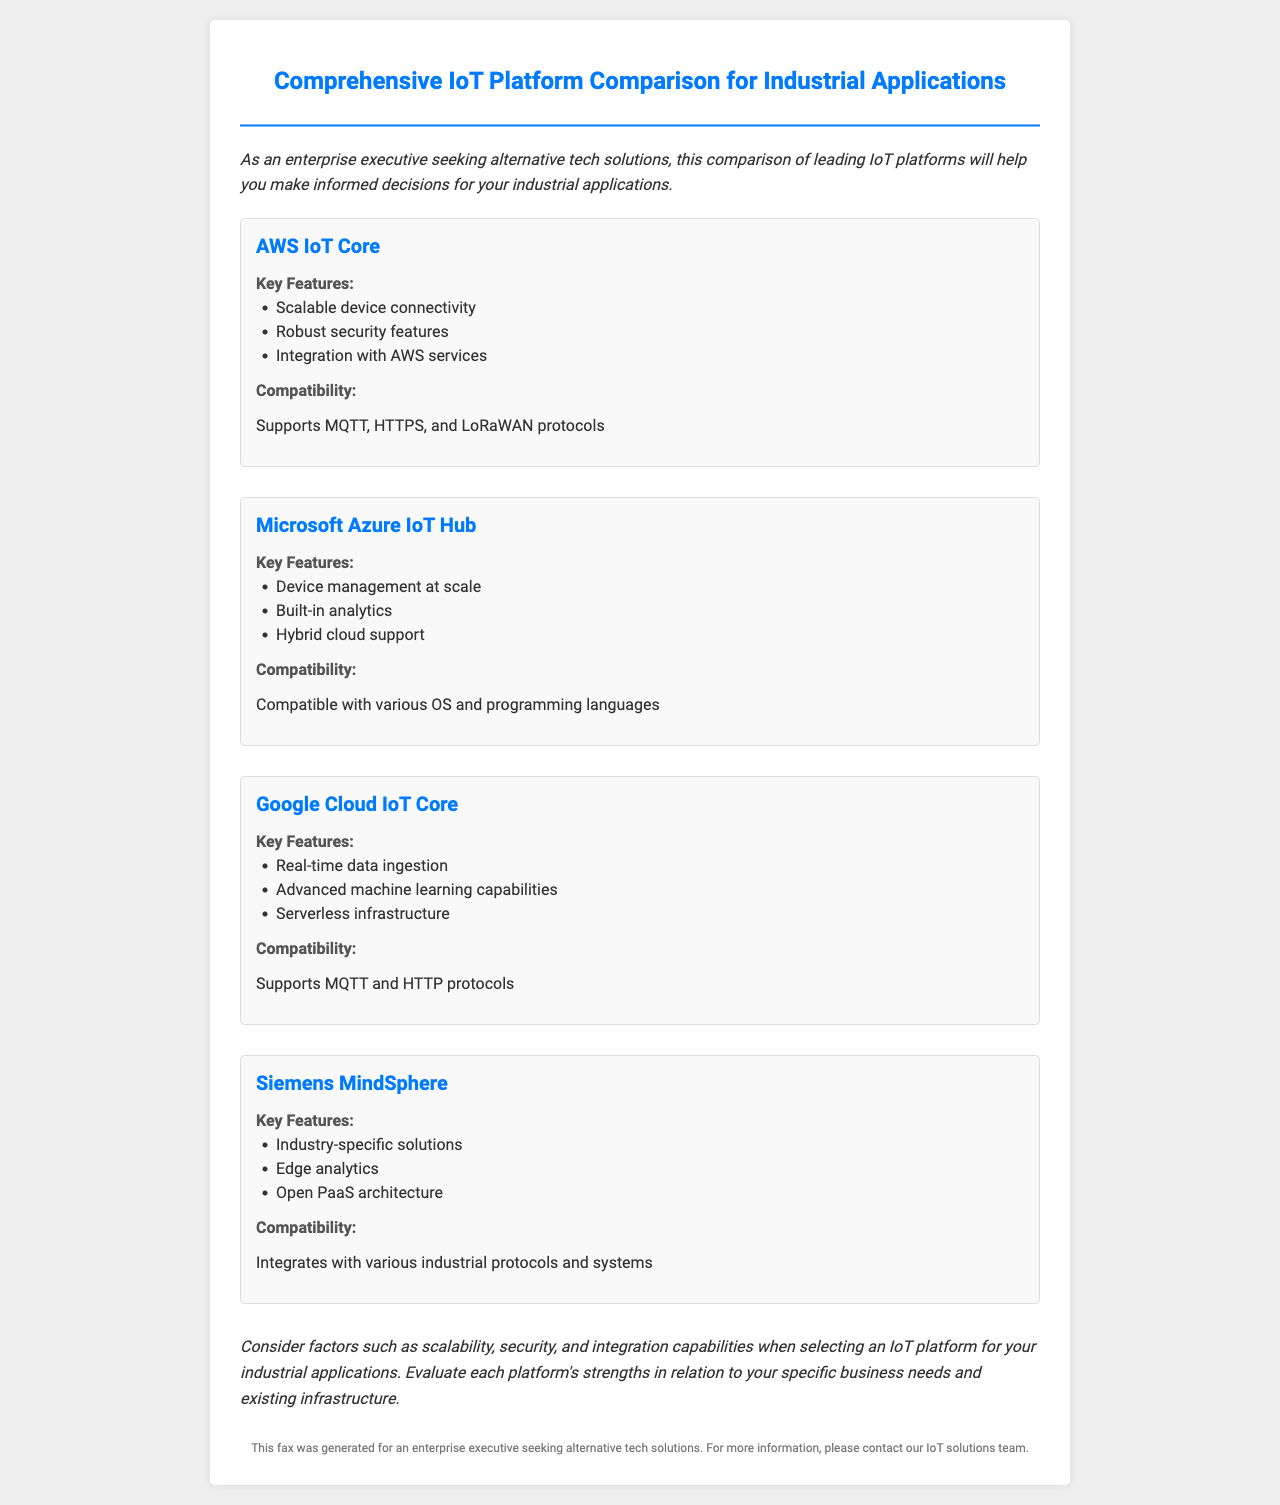what is the title of the document? The title of the document is indicated in the header, which provides an overview of the content.
Answer: Comprehensive IoT Platform Comparison for Industrial Applications how many IoT platforms are compared in the document? The document presents a total of four different IoT platforms for comparison.
Answer: Four what key feature is highlighted for AWS IoT Core? The document lists key features for each platform, with specific emphasis on AWS IoT Core's capabilities.
Answer: Scalable device connectivity which protocol is supported by Google Cloud IoT Core? The compatibility section mentions the supported protocols for Google Cloud IoT Core.
Answer: MQTT and HTTP what is a key feature of Siemens MindSphere? Each platform has distinct key features, and Siemens MindSphere is noted for its specific strengths.
Answer: Industry-specific solutions which platform supports hybrid cloud? The document describes each platform's capabilities related to cloud support.
Answer: Microsoft Azure IoT Hub what is the purpose of this comparison fax? The introduction of the document outlines the objective of providing insights for decision-making.
Answer: Informed decisions for industrial applications what does the conclusion suggest considering for platform selection? The conclusion summarizes key aspects to think about when choosing an IoT platform.
Answer: Scalability, security, and integration capabilities 